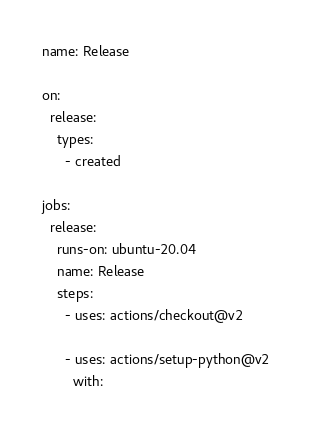Convert code to text. <code><loc_0><loc_0><loc_500><loc_500><_YAML_>name: Release

on:
  release:
    types:
      - created

jobs:
  release:
    runs-on: ubuntu-20.04
    name: Release
    steps:
      - uses: actions/checkout@v2

      - uses: actions/setup-python@v2
        with:</code> 